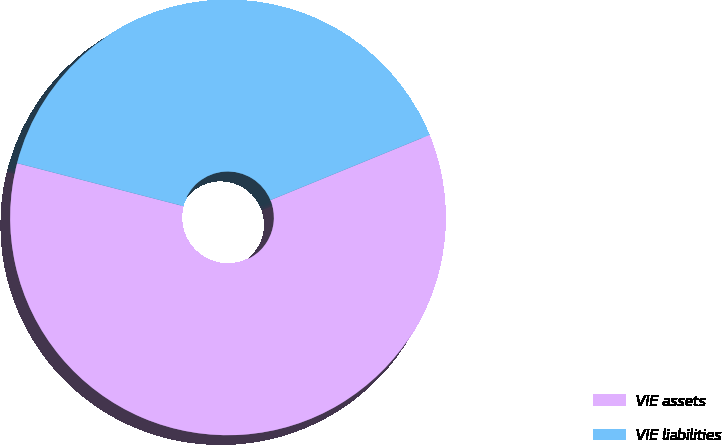Convert chart. <chart><loc_0><loc_0><loc_500><loc_500><pie_chart><fcel>VIE assets<fcel>VIE liabilities<nl><fcel>60.22%<fcel>39.78%<nl></chart> 